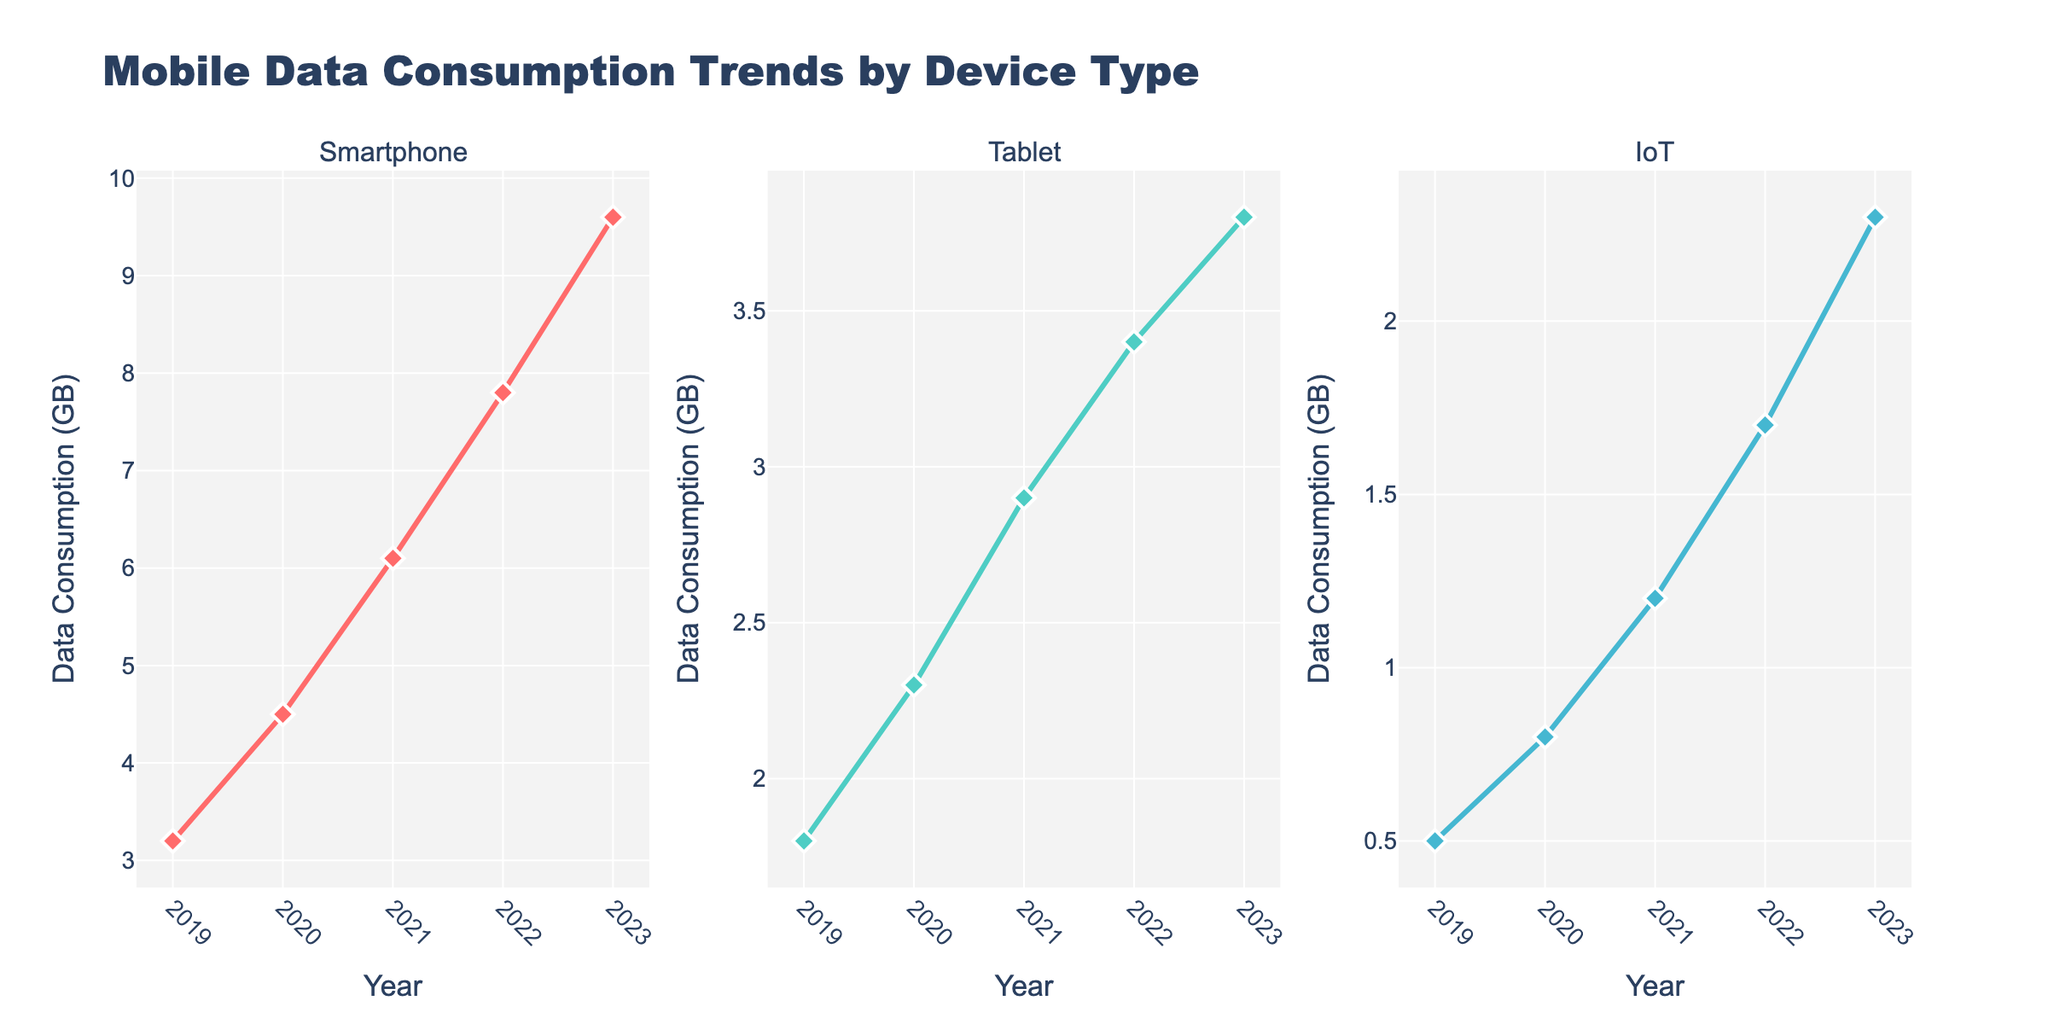Which school has the most popular sports activity and what is it? Look at the sports subplot on the left. The bubble with the largest size represents the most popular activity, which is soccer at Bangkok Patana School with a popularity of 85.
Answer: Bangkok Patana School, Soccer What is the title of the figure? The title is located at the top center of the figure. It is "Extracurricular Activities in Bangkok International Schools".
Answer: Extracurricular Activities in Bangkok International Schools How many schools offer arts-related extracurricular activities? Count the number of bubbles in the middle subplot that represents the arts category. There should be five bubbles, representing five schools.
Answer: 5 What is the difference in popularity between the most popular sports activity and the least popular sports activity? Find the highest and lowest popularity values in the sports subplot. The highest is 85 (soccer) and the lowest is 60 (track and field). Subtract 60 from 85.
Answer: 25 Which academic activity is the most popular and at which school? Look at the right subplot for academic activities. Locate the largest bubble, which indicates the most popular activity. Robotics at NIST International School has a popularity of 70.
Answer: NIST International School, Robotics What is the color used for arts activities? Observe the middle subplot for arts activities and note their bubble color. The color used for arts activities is a shade of teal.
Answer: Teal Which school offers the least popular academic activity and what is its popularity? Look at the right subplot for academic activities. Identify the smallest bubble, representing the least popular activity. Chess Club at Concordian International School has a popularity of 40.
Answer: Concordian International School, 40 Which is more popular: the debate team or the coding club? Compare the popularity values of Debate Team and Coding Club in the academics subplot. Debate Team has a popularity of 50, and Coding Club has a popularity of 60, so Coding Club is more popular.
Answer: Coding Club How many extracurricular activities have a popularity of 60? Check all subplots and count the bubbles with a size indicating a popularity of 60. These activities are Drama Club (Arts), Dance Troupe (Arts), and Track and Field (Sports).
Answer: 3 What is the average popularity of all the sports activities? Add the popularity values of all sports activities: Soccer (85), Swimming (75), Basketball (70), Volleyball (65), and Track and Field (60). Then, divide the sum by 5 (the number of sports activities). The sum is 355, and the average is 355/5.
Answer: 71 